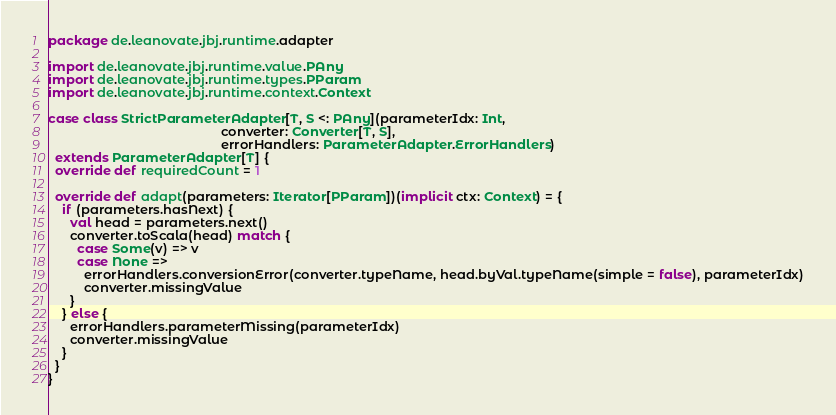<code> <loc_0><loc_0><loc_500><loc_500><_Scala_>package de.leanovate.jbj.runtime.adapter

import de.leanovate.jbj.runtime.value.PAny
import de.leanovate.jbj.runtime.types.PParam
import de.leanovate.jbj.runtime.context.Context

case class StrictParameterAdapter[T, S <: PAny](parameterIdx: Int,
                                                converter: Converter[T, S],
                                                errorHandlers: ParameterAdapter.ErrorHandlers)
  extends ParameterAdapter[T] {
  override def requiredCount = 1

  override def adapt(parameters: Iterator[PParam])(implicit ctx: Context) = {
    if (parameters.hasNext) {
      val head = parameters.next()
      converter.toScala(head) match {
        case Some(v) => v
        case None =>
          errorHandlers.conversionError(converter.typeName, head.byVal.typeName(simple = false), parameterIdx)
          converter.missingValue
      }
    } else {
      errorHandlers.parameterMissing(parameterIdx)
      converter.missingValue
    }
  }
}
</code> 